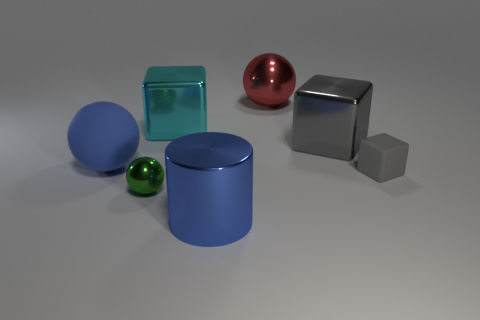Subtract all red cubes. Subtract all yellow cylinders. How many cubes are left? 3 Add 3 tiny purple spheres. How many objects exist? 10 Subtract all spheres. How many objects are left? 4 Add 1 large things. How many large things exist? 6 Subtract 0 purple cylinders. How many objects are left? 7 Subtract all cyan metallic cubes. Subtract all big matte objects. How many objects are left? 5 Add 2 tiny metallic balls. How many tiny metallic balls are left? 3 